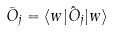Convert formula to latex. <formula><loc_0><loc_0><loc_500><loc_500>\bar { O } _ { j } = \langle w | \hat { O } _ { j } | w \rangle</formula> 